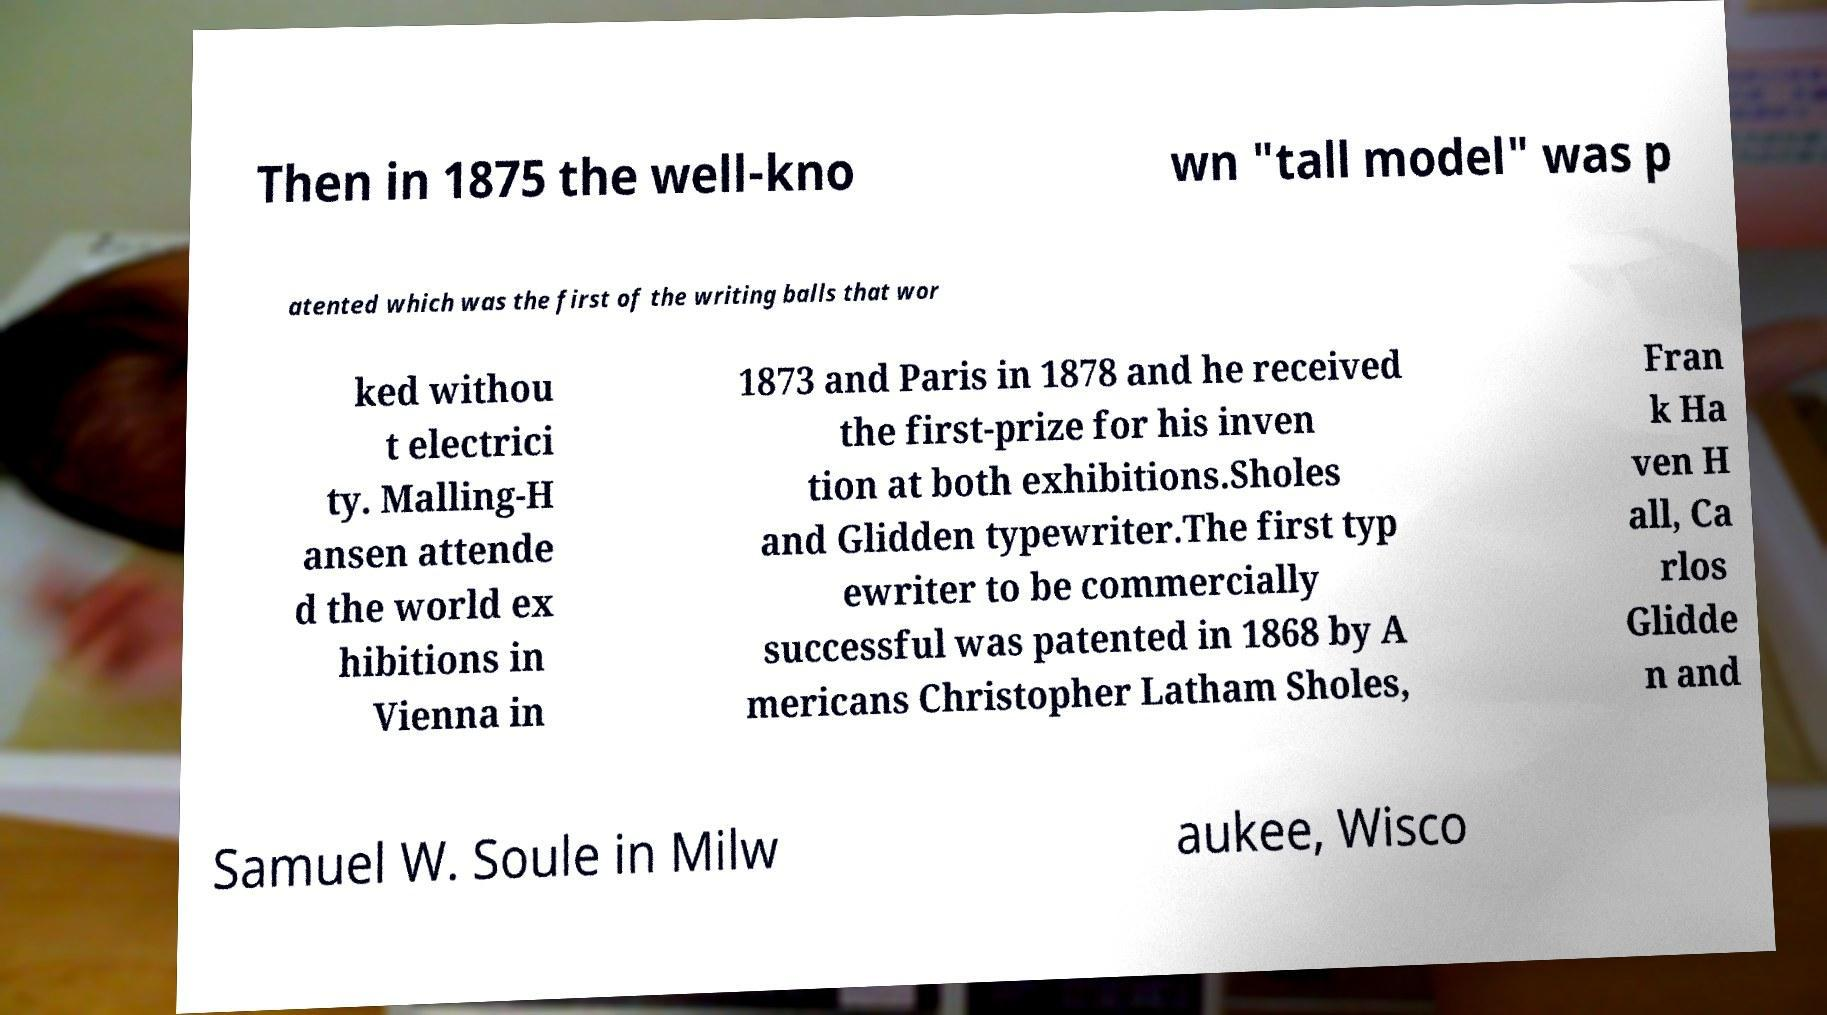Can you accurately transcribe the text from the provided image for me? Then in 1875 the well-kno wn "tall model" was p atented which was the first of the writing balls that wor ked withou t electrici ty. Malling-H ansen attende d the world ex hibitions in Vienna in 1873 and Paris in 1878 and he received the first-prize for his inven tion at both exhibitions.Sholes and Glidden typewriter.The first typ ewriter to be commercially successful was patented in 1868 by A mericans Christopher Latham Sholes, Fran k Ha ven H all, Ca rlos Glidde n and Samuel W. Soule in Milw aukee, Wisco 